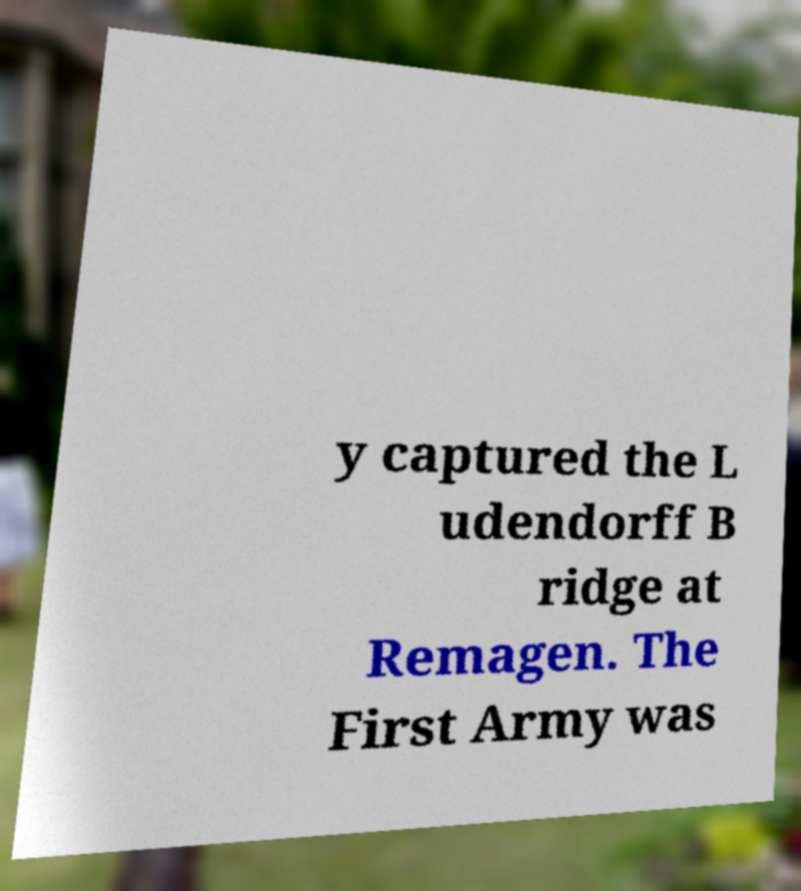Could you extract and type out the text from this image? y captured the L udendorff B ridge at Remagen. The First Army was 